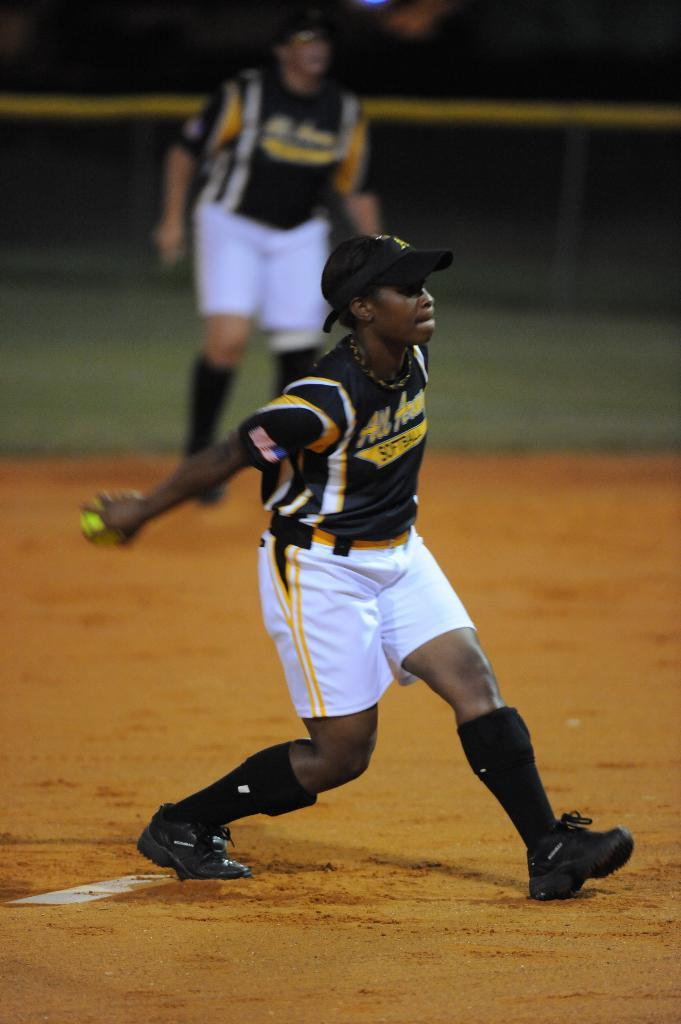<image>
Summarize the visual content of the image. Athlete wearing a white and black jersey that says All American on it. 